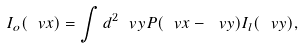<formula> <loc_0><loc_0><loc_500><loc_500>I _ { o } ( \ v x ) = \int d ^ { 2 } \ v y P ( \ v x - \ v y ) I _ { l } ( \ v y ) ,</formula> 